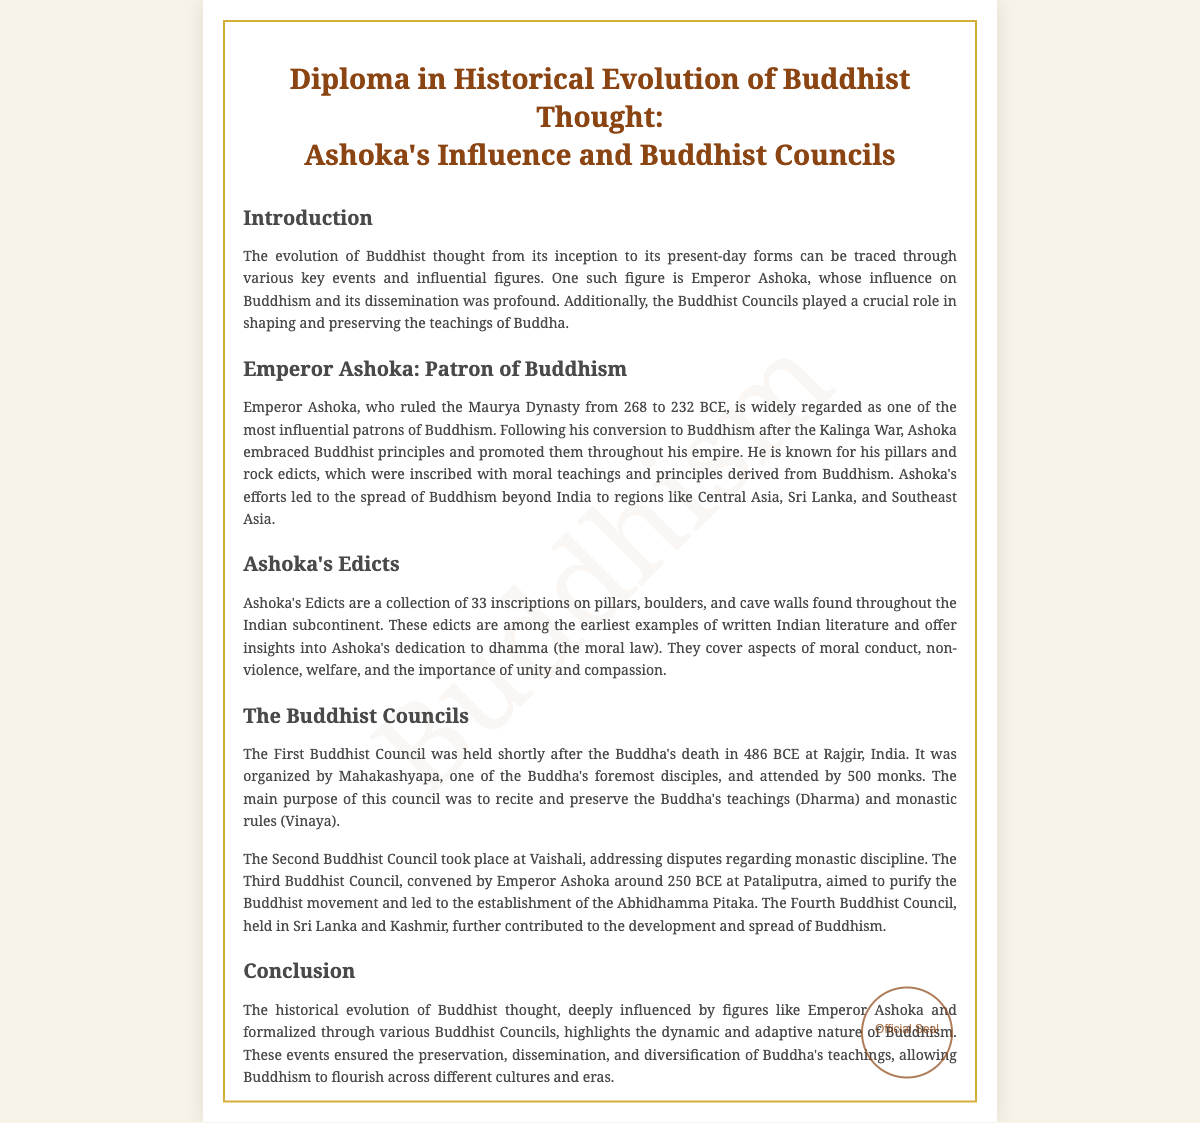What is the title of the diploma? The title of the diploma is presented prominently at the top of the document.
Answer: Diploma in Historical Evolution of Buddhist Thought: Ashoka's Influence and Buddhist Councils Who organized the First Buddhist Council? The document states that Mahakashyapa organized the First Buddhist Council.
Answer: Mahakashyapa What year did Ashoka rule the Maurya Dynasty? The diploma specifies Ashoka's reign years as from 268 to 232 BCE.
Answer: 268 to 232 BCE What is the main purpose of the Second Buddhist Council? The document states that the Second Buddhist Council addressed disputes regarding monastic discipline.
Answer: Disputes regarding monastic discipline How many edicts are part of Ashoka's Edicts? The document mentions that Ashoka's Edicts consist of 33 inscriptions.
Answer: 33 What significant event did Ashoka undergo after the Kalinga War? According to the document, Ashoka converted to Buddhism after the Kalinga War.
Answer: Converted to Buddhism Where was the Third Buddhist Council convened? The diploma specifies that the Third Buddhist Council was convened at Pataliputra.
Answer: Pataliputra Which document section discusses the impact of Ashoka on Buddhism? The section titled "Emperor Ashoka: Patron of Buddhism" discusses Ashoka's impact.
Answer: Emperor Ashoka: Patron of Buddhism What does "dhamma" refer to in Ashoka's Edicts? The document explains that "dhamma" refers to the moral law in the context of Ashoka's Edicts.
Answer: Moral law 